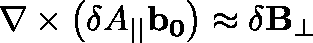<formula> <loc_0><loc_0><loc_500><loc_500>\nabla \times \left ( \delta A _ { | | } b _ { 0 } \right ) \approx \delta B _ { \perp }</formula> 